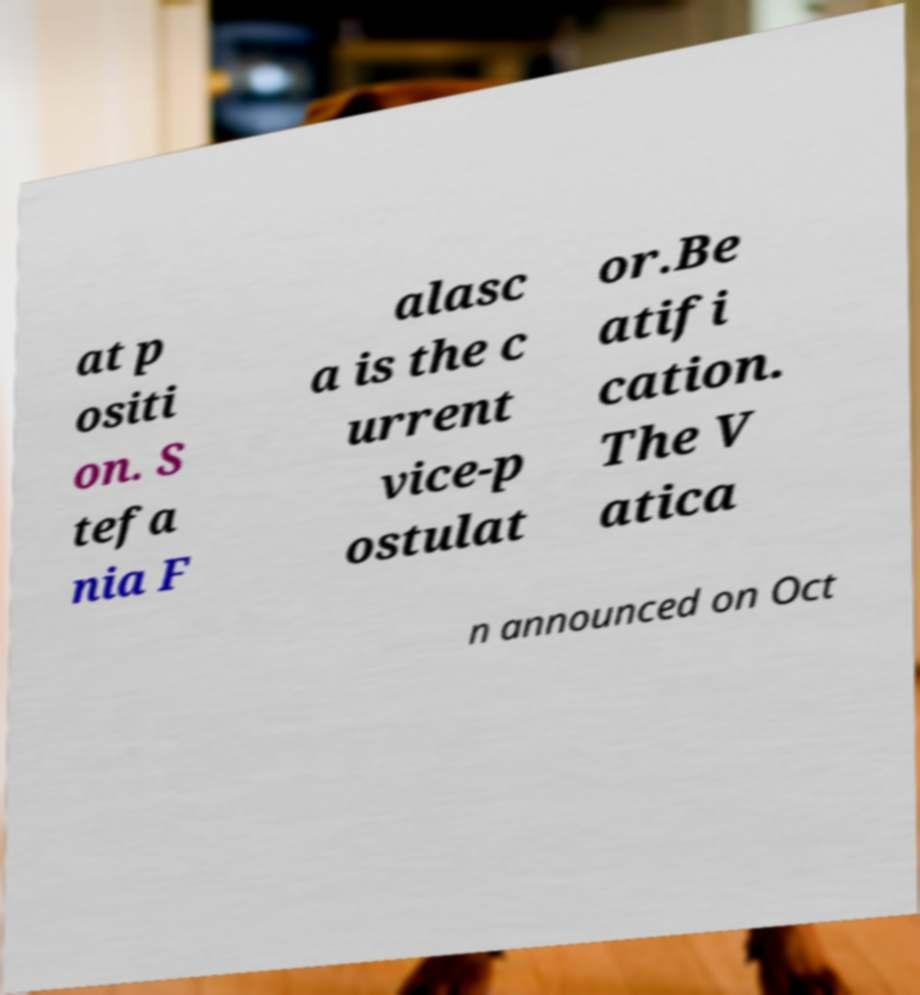Could you extract and type out the text from this image? at p ositi on. S tefa nia F alasc a is the c urrent vice-p ostulat or.Be atifi cation. The V atica n announced on Oct 